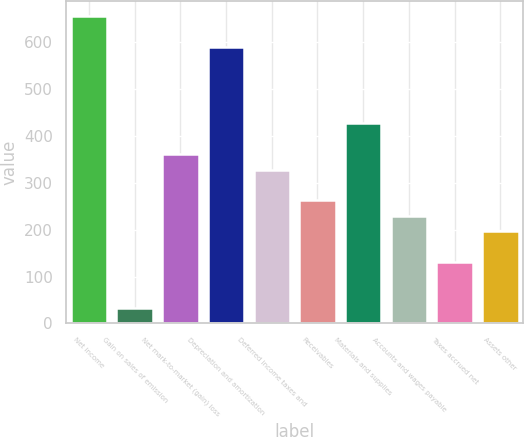Convert chart. <chart><loc_0><loc_0><loc_500><loc_500><bar_chart><fcel>Net income<fcel>Gain on sales of emission<fcel>Net mark-to-market (gain) loss<fcel>Depreciation and amortization<fcel>Deferred income taxes and<fcel>Receivables<fcel>Materials and supplies<fcel>Accounts and wages payable<fcel>Taxes accrued net<fcel>Assets other<nl><fcel>655<fcel>33.7<fcel>360.7<fcel>589.6<fcel>328<fcel>262.6<fcel>426.1<fcel>229.9<fcel>131.8<fcel>197.2<nl></chart> 